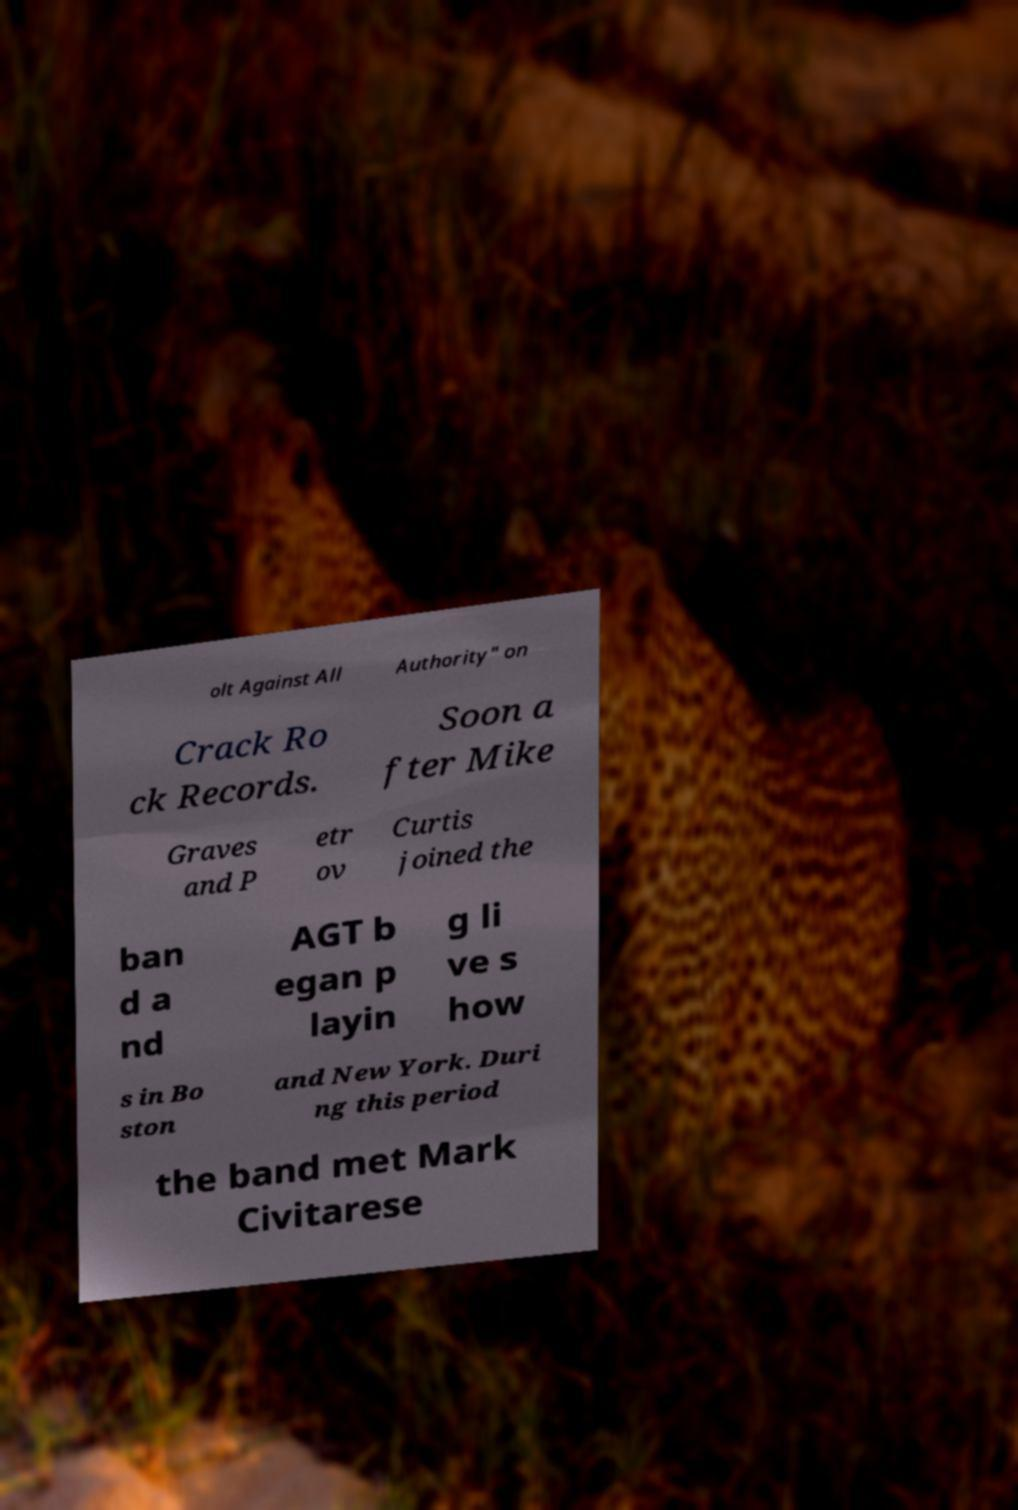There's text embedded in this image that I need extracted. Can you transcribe it verbatim? olt Against All Authority" on Crack Ro ck Records. Soon a fter Mike Graves and P etr ov Curtis joined the ban d a nd AGT b egan p layin g li ve s how s in Bo ston and New York. Duri ng this period the band met Mark Civitarese 